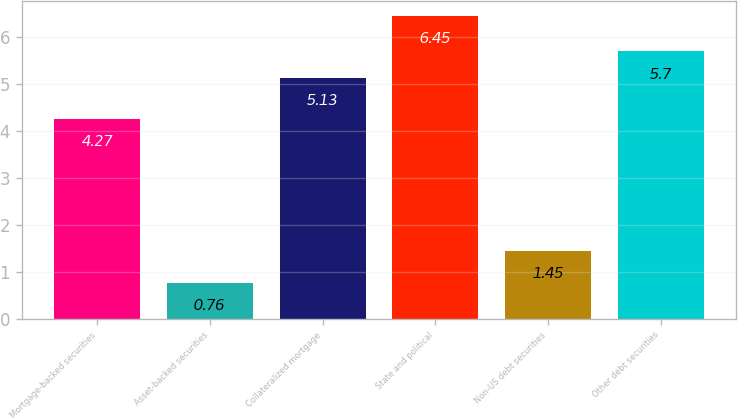Convert chart. <chart><loc_0><loc_0><loc_500><loc_500><bar_chart><fcel>Mortgage-backed securities<fcel>Asset-backed securities<fcel>Collateralized mortgage<fcel>State and political<fcel>Non-US debt securities<fcel>Other debt securities<nl><fcel>4.27<fcel>0.76<fcel>5.13<fcel>6.45<fcel>1.45<fcel>5.7<nl></chart> 